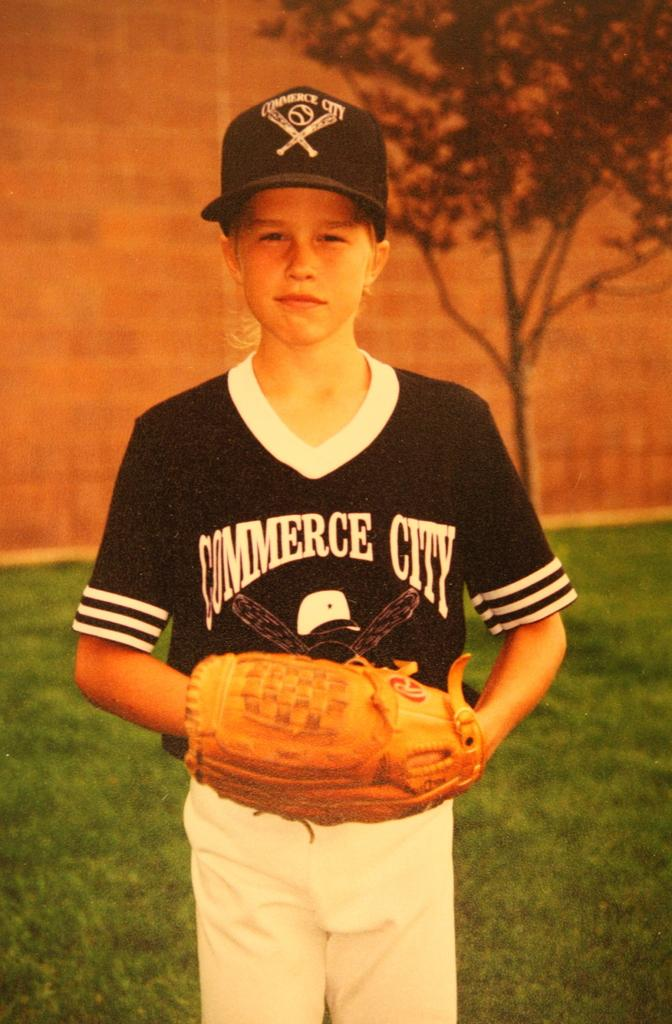<image>
Present a compact description of the photo's key features. a jersey with the words Commerce City on it 